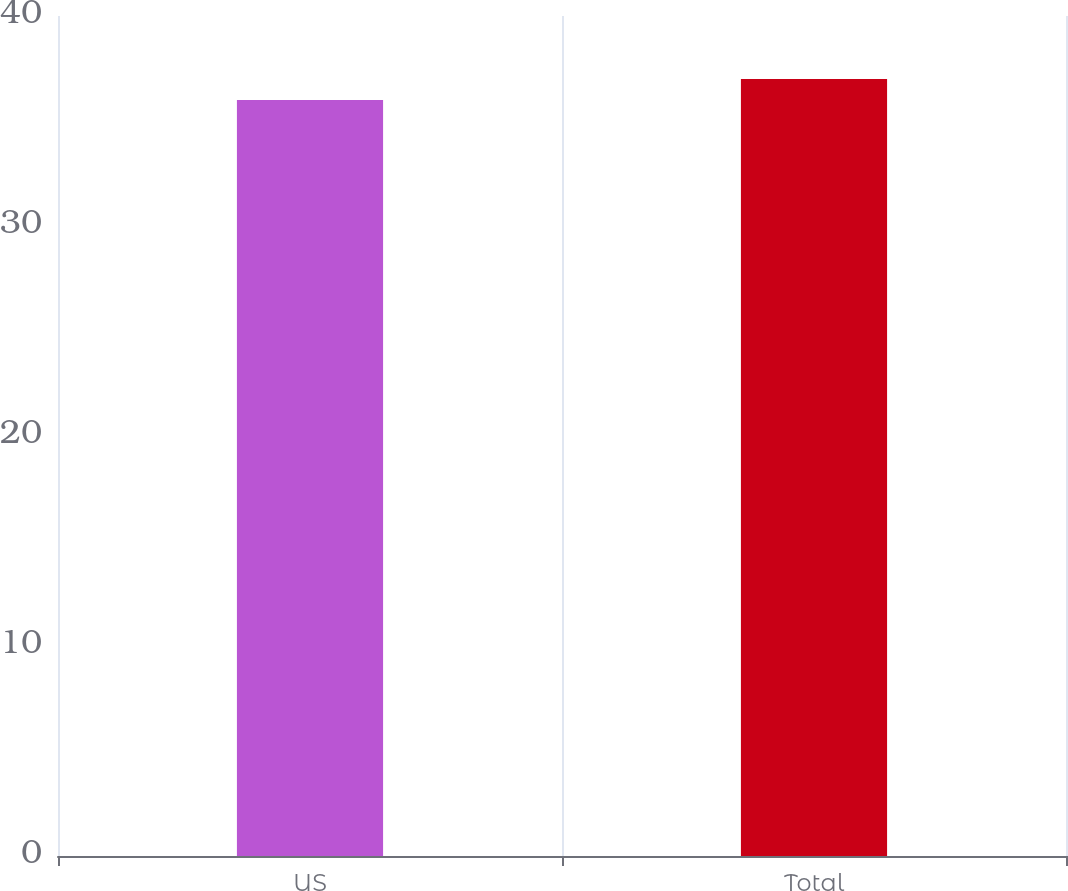Convert chart to OTSL. <chart><loc_0><loc_0><loc_500><loc_500><bar_chart><fcel>US<fcel>Total<nl><fcel>36<fcel>37<nl></chart> 